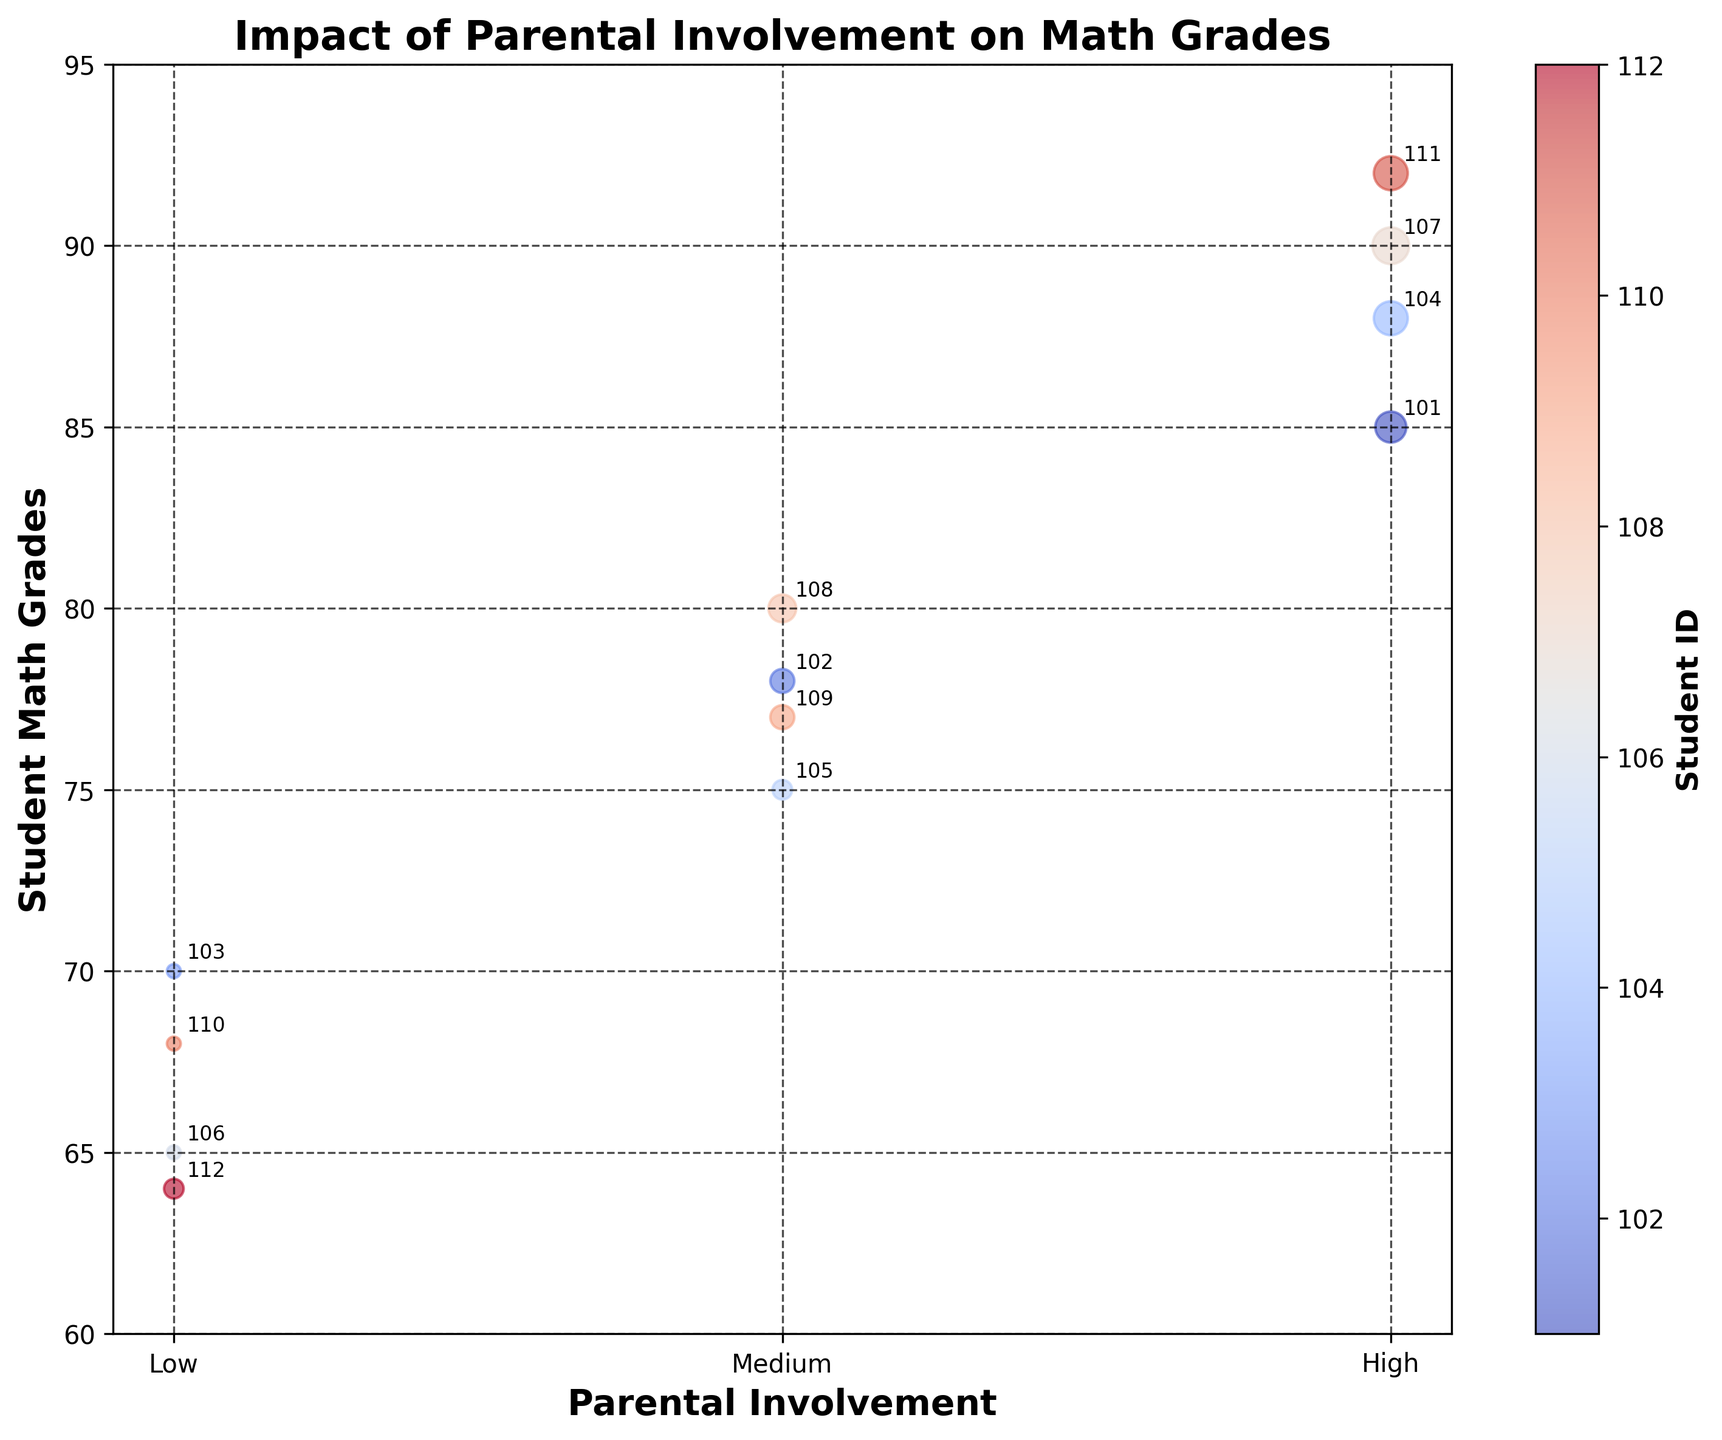How many categories of Parental Involvement are there? There are three distinct categories of Parental Involvement shown on the x-axis of the chart: 'Low', 'Medium', and 'High'.
Answer: Three What is the highest Student Math Grade achieved among students with High Parental Involvement? To find the highest grade, we need to look at the y-axis values for 'High' Parental Involvement. The highest value is 92.
Answer: 92 Which category of Parental Involvement has the bubble with the smallest size? The bubble size corresponds to the Hours of Parental Math Support per Week. The smallest bubble sizes are correlated with Values of 'Low' Parental Involvement, with 1 hours per week each.
Answer: Low What is the average Student Math Grade of students with Medium Parental Involvement? The grades for Medium Parental Involvement are 78, 75, 80, and 77. The average is calculated as (78 + 75 + 80 + 77) / 4 = 77.5.
Answer: 77.5 Which student number corresponds to the highest grade in the chart? The highest grade shown on the y-axis is 92, and it is annotated with Student ID 111.
Answer: 111 Compare the highest math grade between students with Low and High Parental Involvement. The highest grade among students with Low Parental Involvement is 70, while among those with High Parental Involvement, it is 92. Therefore, the highest grade in the High category exceeds that in the Low category by 22 points.
Answer: High exceeds Low by 22 points Does any student with Low Parental Involvement achieve a grade higher than students with Medium Parental Involvement? Observing students with Low Parental Involvement, the highest grade is 70. Comparing this to Medium Parental Involvement, the lowest grade is 75. Thus, no student with Low Parental Involvement outperformed those with Medium Involvement.
Answer: No What is the range of Student Math Grades among students with High Parental Involvement? For High Parental Involvement, the grades are 85, 88, 90, and 92. The range is calculated as the difference between the maximum and minimum values: 92 - 85 = 7.
Answer: 7 How many students have more than 5 hours of parental math support per week? The bubbles indicating the largest sizes represent hours greater than 5. Students 104, 107, and 111 have 6, 7, and 6 hours, respectively. Therefore, there are three students.
Answer: 3 Is there a visible trend between Parental Involvement and Student Math Grades? Yes, by examining the positions of the bubbles, it's clear that higher levels of Parental Involvement correspond to higher Student Math Grades. Low involvement clusters lower on the y-axis, whereas high involvement clusters higher.
Answer: Yes 